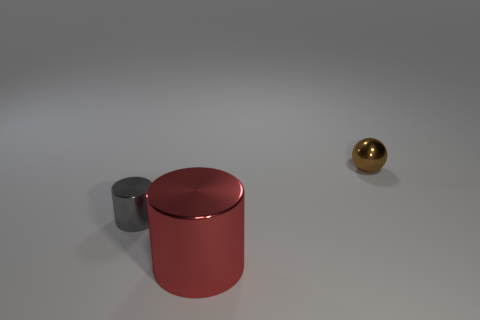What number of cylinders are on the left side of the big red cylinder?
Offer a terse response. 1. Is there a sphere?
Provide a succinct answer. Yes. There is a object that is on the right side of the cylinder to the right of the small thing on the left side of the brown shiny ball; what is its color?
Ensure brevity in your answer.  Brown. There is a tiny thing that is to the left of the small sphere; are there any gray cylinders left of it?
Your answer should be compact. No. Does the small metallic object that is in front of the tiny shiny ball have the same color as the thing on the right side of the big red cylinder?
Your response must be concise. No. What number of other metallic balls have the same size as the brown ball?
Offer a terse response. 0. There is a object that is in front of the gray metallic cylinder; is its size the same as the shiny ball?
Provide a succinct answer. No. What shape is the tiny brown metallic object?
Ensure brevity in your answer.  Sphere. Are the small thing to the right of the large red shiny cylinder and the red thing made of the same material?
Your answer should be compact. Yes. Is there a tiny metallic sphere of the same color as the large object?
Keep it short and to the point. No. 